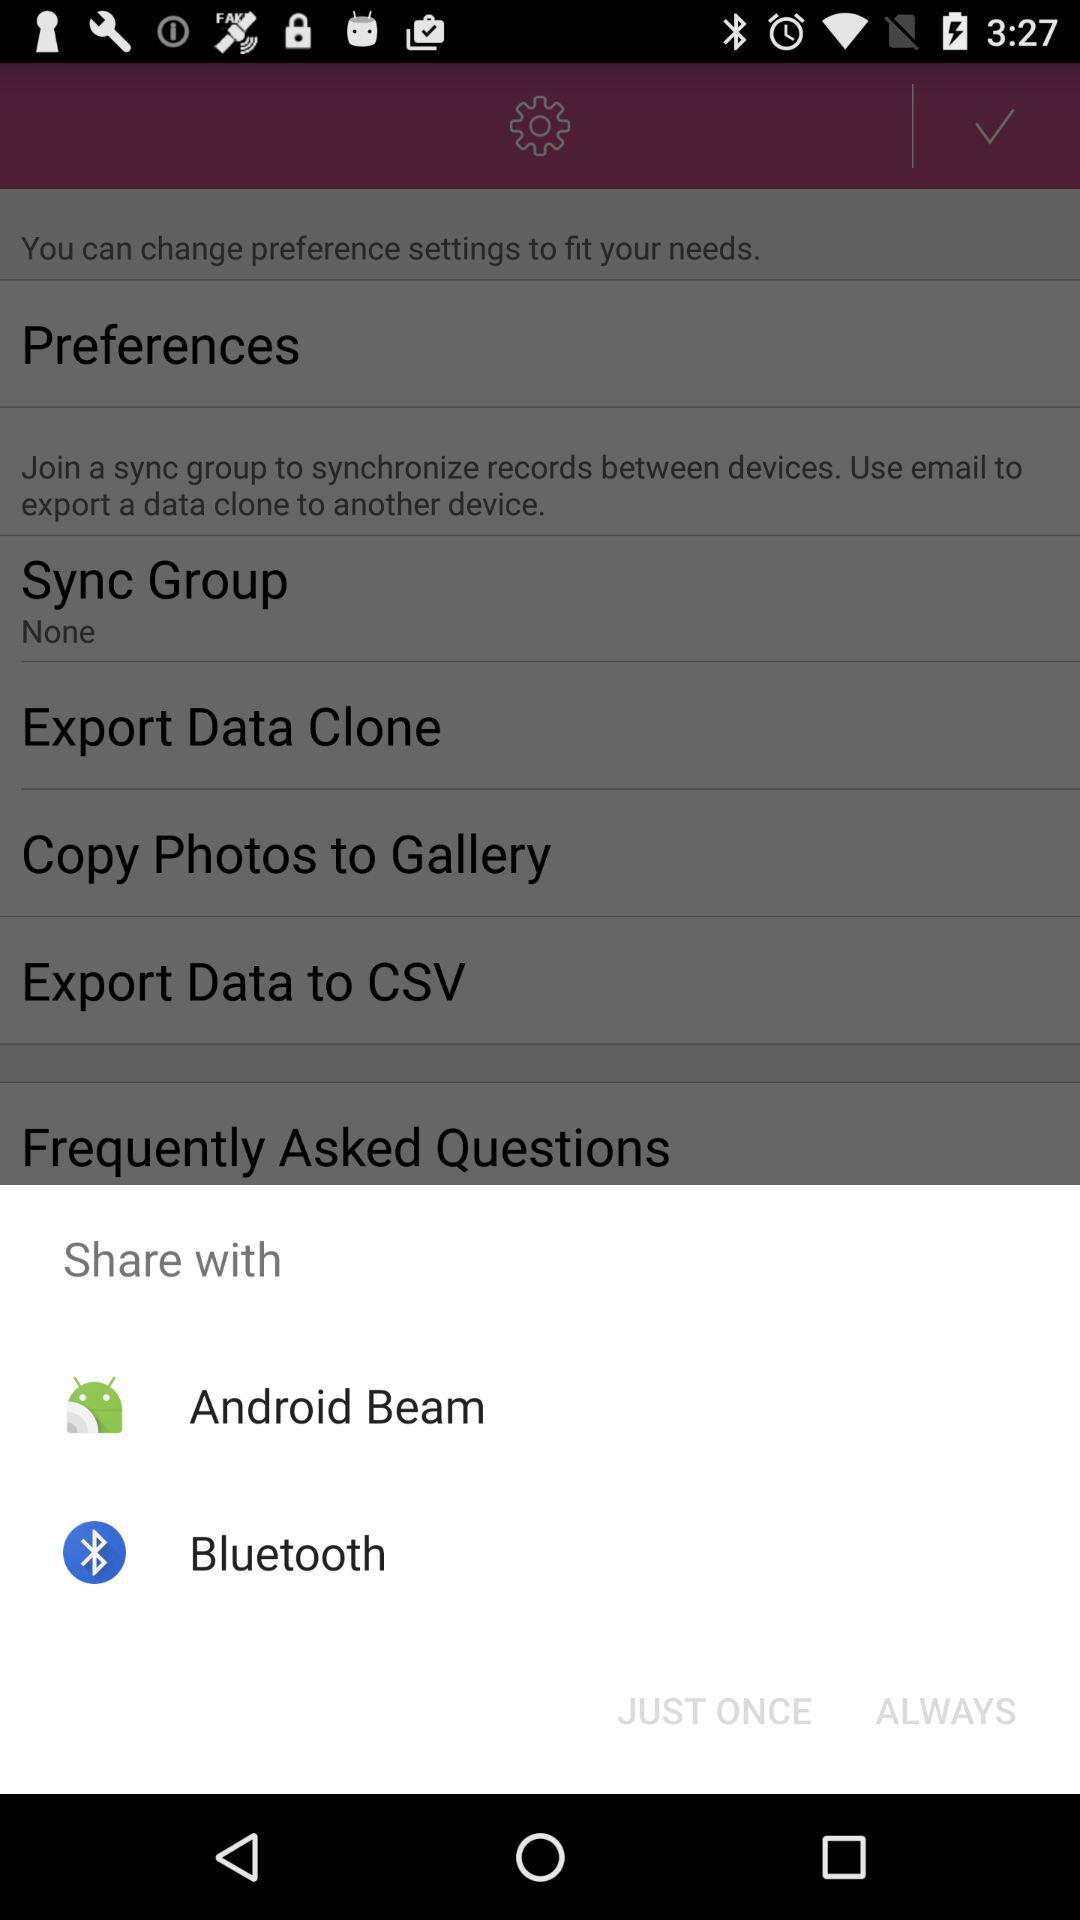By which app can we share it? You can share it by "Android Beam" and "Bluetooth". 